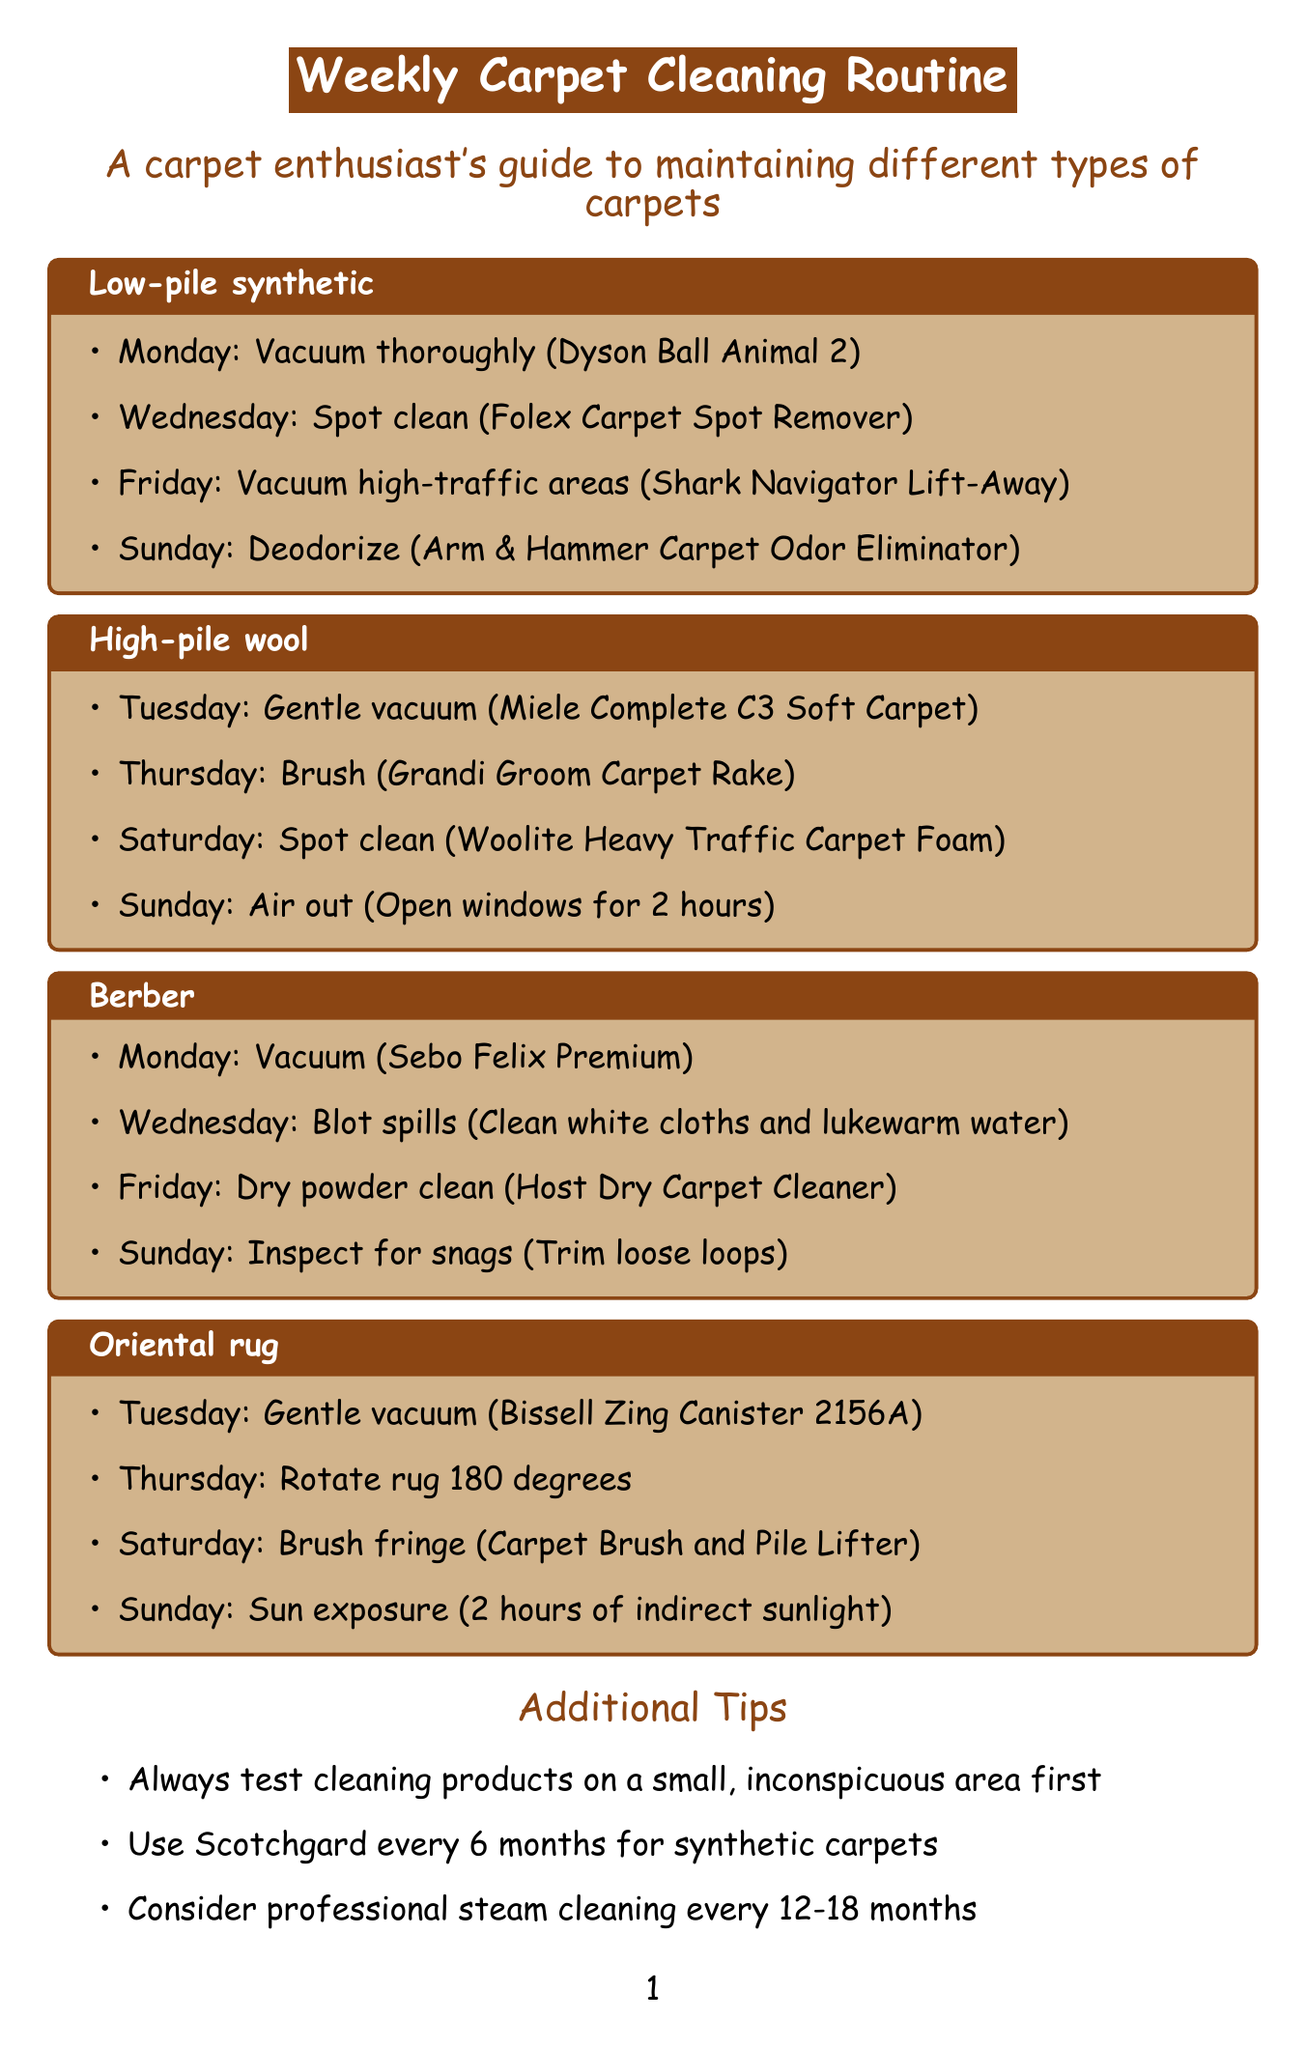what type of vacuum should be used on low-pile synthetic carpets? The document specifies using a Dyson Ball Animal 2 upright vacuum with brush roll engaged for low-pile synthetic carpets.
Answer: Dyson Ball Animal 2 which day is designated for spot cleaning high-pile wool carpets? The schedule indicates that spot cleaning for high-pile wool carpets should be done on Saturday using a wool-safe cleaner.
Answer: Saturday how many steps are there for cleaning Berber carpets each week? The document outlines a total of four steps for cleaning Berber carpets, each assigned to a different day.
Answer: Four what is the primary task on Sundays for Oriental rugs? The Sunday task for Oriental rugs involves exposing them to indirect sunlight for natural disinfection.
Answer: Sun exposure when should you deodorize low-pile synthetic carpets? According to the schedule, deodorizing low-pile synthetic carpets should occur on Sunday with Arm & Hammer Carpet Odor Eliminator.
Answer: Sunday which additional tip is recommended for synthetic carpets? The document advises using a carpet protector like Scotchgard every 6 months for synthetic carpets.
Answer: Scotchgard every 6 months what is used to brush the fringe of Oriental rugs? The cleaning routine specifies using a Carpet Brush and Pile Lifter by Grandi Groom for brushing the fringe of Oriental rugs.
Answer: Carpet Brush and Pile Lifter how often should professional steam cleaning be considered? The document suggests considering professional steam cleaning every 12-18 months for deep cleaning.
Answer: 12-18 months what is the oldest known carpet mentioned in the document? The document refers to the Pazyryk carpet, which dates back to the 5th century BC.
Answer: Pazyryk carpet 